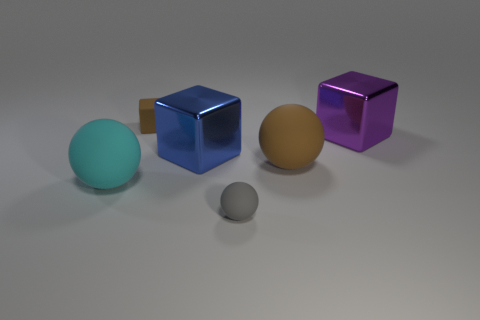Are there fewer big cyan rubber balls that are on the right side of the purple object than small objects behind the cyan object?
Ensure brevity in your answer.  Yes. Is there anything else that is the same color as the matte block?
Give a very brief answer. Yes. What number of large things are metal cylinders or purple shiny things?
Keep it short and to the point. 1. How many things are large matte balls behind the big cyan sphere or small cyan matte cylinders?
Your answer should be compact. 1. What number of green objects are either small matte spheres or metallic things?
Your response must be concise. 0. What is the color of the other object that is the same material as the blue object?
Your answer should be compact. Purple. Do the small thing in front of the tiny brown matte cube and the large cube that is right of the small gray object have the same material?
Give a very brief answer. No. The ball that is the same color as the tiny block is what size?
Your answer should be compact. Large. There is a large block that is on the left side of the tiny gray rubber sphere; what material is it?
Give a very brief answer. Metal. Is the shape of the tiny rubber thing that is behind the blue thing the same as the large metal thing that is right of the tiny ball?
Keep it short and to the point. Yes. 